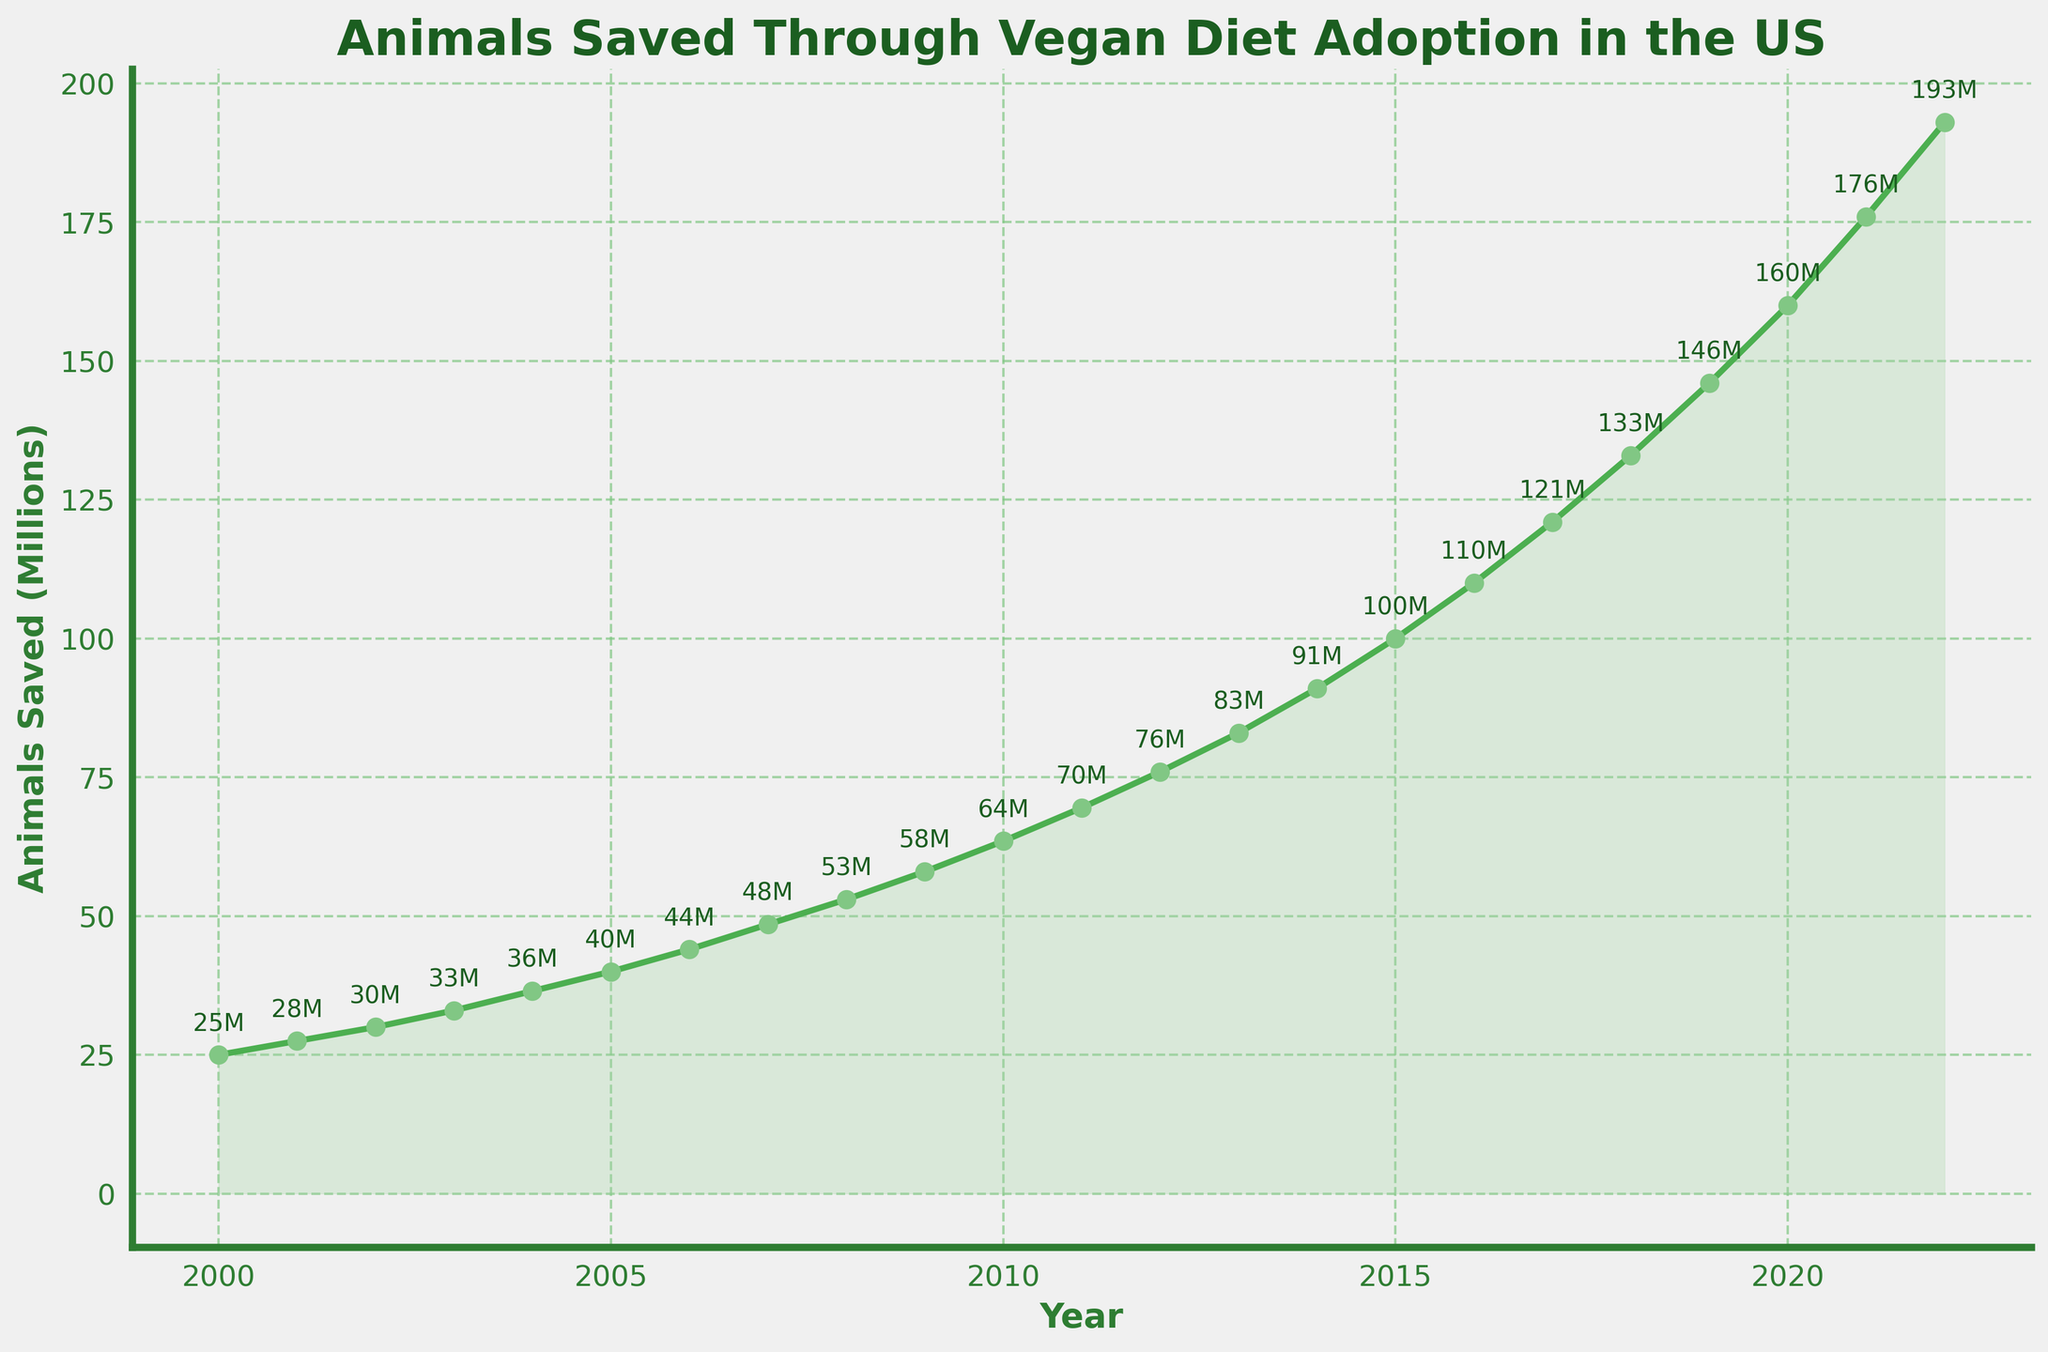What year had the highest number of animals saved? Look at the point on the line chart where the 'Animals Saved' value is the highest. The highest number is at the end of the timeline.
Answer: 2022 How many more animals were saved in 2022 compared to 2000? Find the difference between the number of animals saved in 2022 and 2000 by subtracting the value for 2000 from the value for 2022.
Answer: 168,000,000 Between which consecutive years did the number of animals saved increase the most? Look for the largest gap between consecutive points on the line chart. Visually, the largest increase appears to be between the last two points.
Answer: 2021 to 2022 What is the average number of animals saved per year between 2000 and 2010? Sum the number of animals saved from 2000 to 2010 and then divide by the number of years (11). (25000000 + 27500000 + 30000000 + 33000000 + 36500000 + 40000000 + 44000000 + 48500000 + 53000000 + 58000000 + 63500000)/11 = 44772727
Answer: ~44,772,727 How many times did the number of animals saved increase by more than 5 million between consecutive years? Count the number of times the vertical distance between points (consecutive years) on the line chart appears to be greater than 5 million.
Answer: 22 Is the growth in the number of animals saved linear or exponential? Examine the shape of the line. An exponential growth curve will show an increasingly steeper slope, while a linear growth curve will show a consistent slope. The curve increases steeply at the end, suggesting exponential growth.
Answer: Exponential What is the median number of animals saved from 2000 to 2022? List the number of animals saved in each year, sort them, and find the middle value. With 23 values, the median is the 12th value in the sorted list.
Answer: 76,000,000 Compare the number of animals saved in the first half of the period (2000-2011) to the second half (2012-2022). Which half saved more animals? Sum the values from 2000 to 2011 and compare it to the sum from 2012 to 2022. (2000-2011: 2.295 billion, 2012-2022: 1.763 billion)
Answer: First half What was the annual growth rate in the number of animals saved between 2010 and 2020? Calculate the growth by dividing the difference in the number of animals saved in 2020 and 2010 by the number of years (10) and then dividing by the 2010 value, converting it to a percentage. (160M - 63.5M)/63.5M/10 * 100
Answer: ~15.09% 